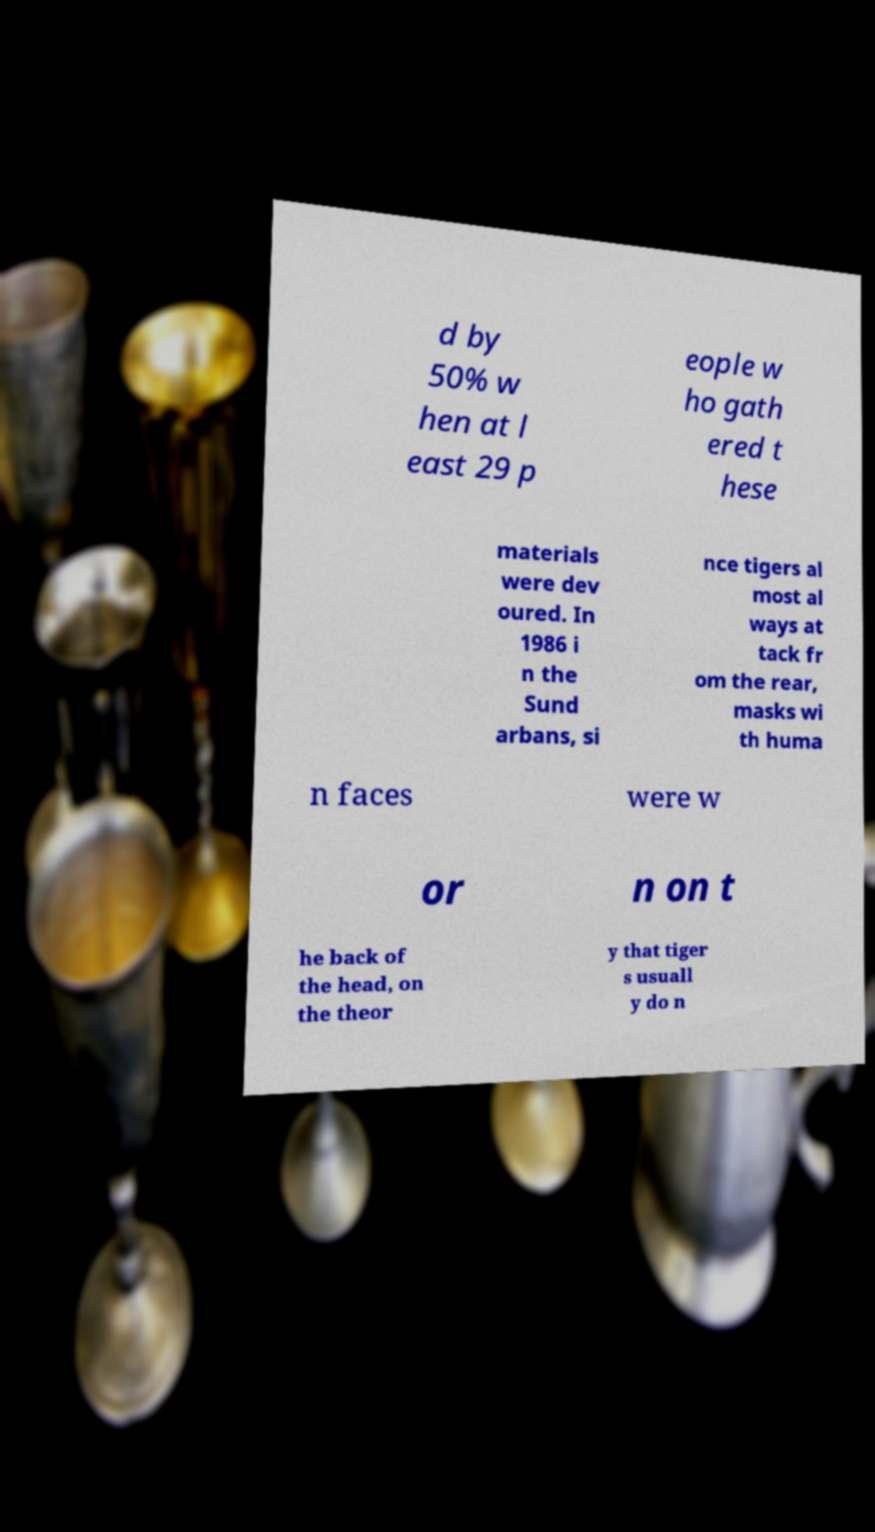Could you assist in decoding the text presented in this image and type it out clearly? d by 50% w hen at l east 29 p eople w ho gath ered t hese materials were dev oured. In 1986 i n the Sund arbans, si nce tigers al most al ways at tack fr om the rear, masks wi th huma n faces were w or n on t he back of the head, on the theor y that tiger s usuall y do n 